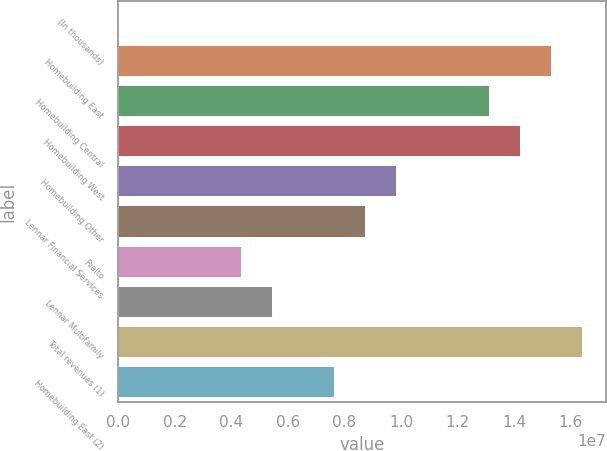Convert chart to OTSL. <chart><loc_0><loc_0><loc_500><loc_500><bar_chart><fcel>(In thousands)<fcel>Homebuilding East<fcel>Homebuilding Central<fcel>Homebuilding West<fcel>Homebuilding Other<fcel>Lennar Financial Services<fcel>Rialto<fcel>Lennar Multifamily<fcel>Total revenues (1)<fcel>Homebuilding East (2)<nl><fcel>2016<fcel>1.53292e+07<fcel>1.31396e+07<fcel>1.42344e+07<fcel>9.8552e+06<fcel>8.7604e+06<fcel>4.38121e+06<fcel>5.47601e+06<fcel>1.6424e+07<fcel>7.6656e+06<nl></chart> 